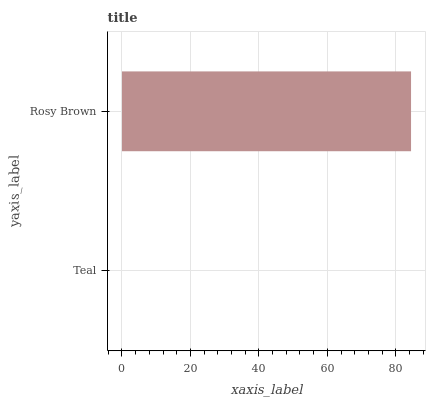Is Teal the minimum?
Answer yes or no. Yes. Is Rosy Brown the maximum?
Answer yes or no. Yes. Is Rosy Brown the minimum?
Answer yes or no. No. Is Rosy Brown greater than Teal?
Answer yes or no. Yes. Is Teal less than Rosy Brown?
Answer yes or no. Yes. Is Teal greater than Rosy Brown?
Answer yes or no. No. Is Rosy Brown less than Teal?
Answer yes or no. No. Is Rosy Brown the high median?
Answer yes or no. Yes. Is Teal the low median?
Answer yes or no. Yes. Is Teal the high median?
Answer yes or no. No. Is Rosy Brown the low median?
Answer yes or no. No. 